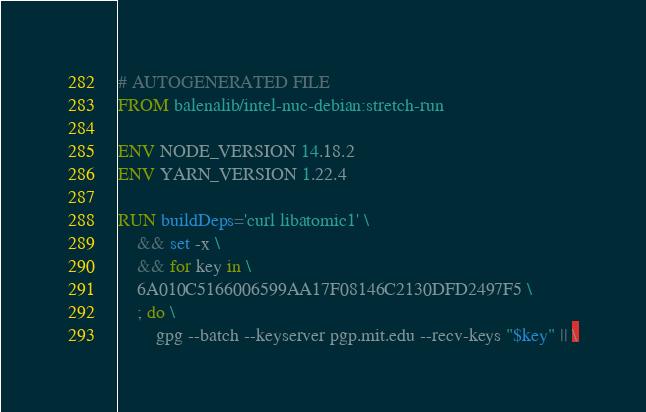Convert code to text. <code><loc_0><loc_0><loc_500><loc_500><_Dockerfile_># AUTOGENERATED FILE
FROM balenalib/intel-nuc-debian:stretch-run

ENV NODE_VERSION 14.18.2
ENV YARN_VERSION 1.22.4

RUN buildDeps='curl libatomic1' \
	&& set -x \
	&& for key in \
	6A010C5166006599AA17F08146C2130DFD2497F5 \
	; do \
		gpg --batch --keyserver pgp.mit.edu --recv-keys "$key" || \</code> 